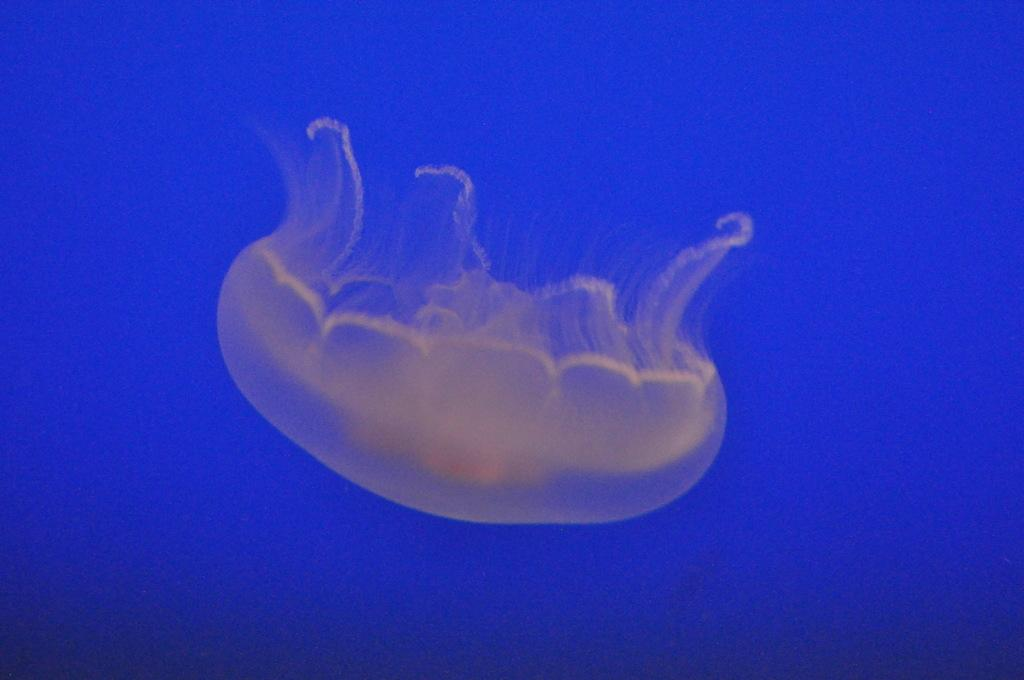What is the main subject of the image? There is a jellyfish in the image. What color is the background of the image? The background of the image is blue. What type of country is depicted in the image? There is no country present in the image; it features a jellyfish in a blue background. How does the sand interact with the jellyfish in the image? There is no sand present in the image; it only features a jellyfish in a blue background. 